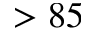<formula> <loc_0><loc_0><loc_500><loc_500>> 8 5</formula> 